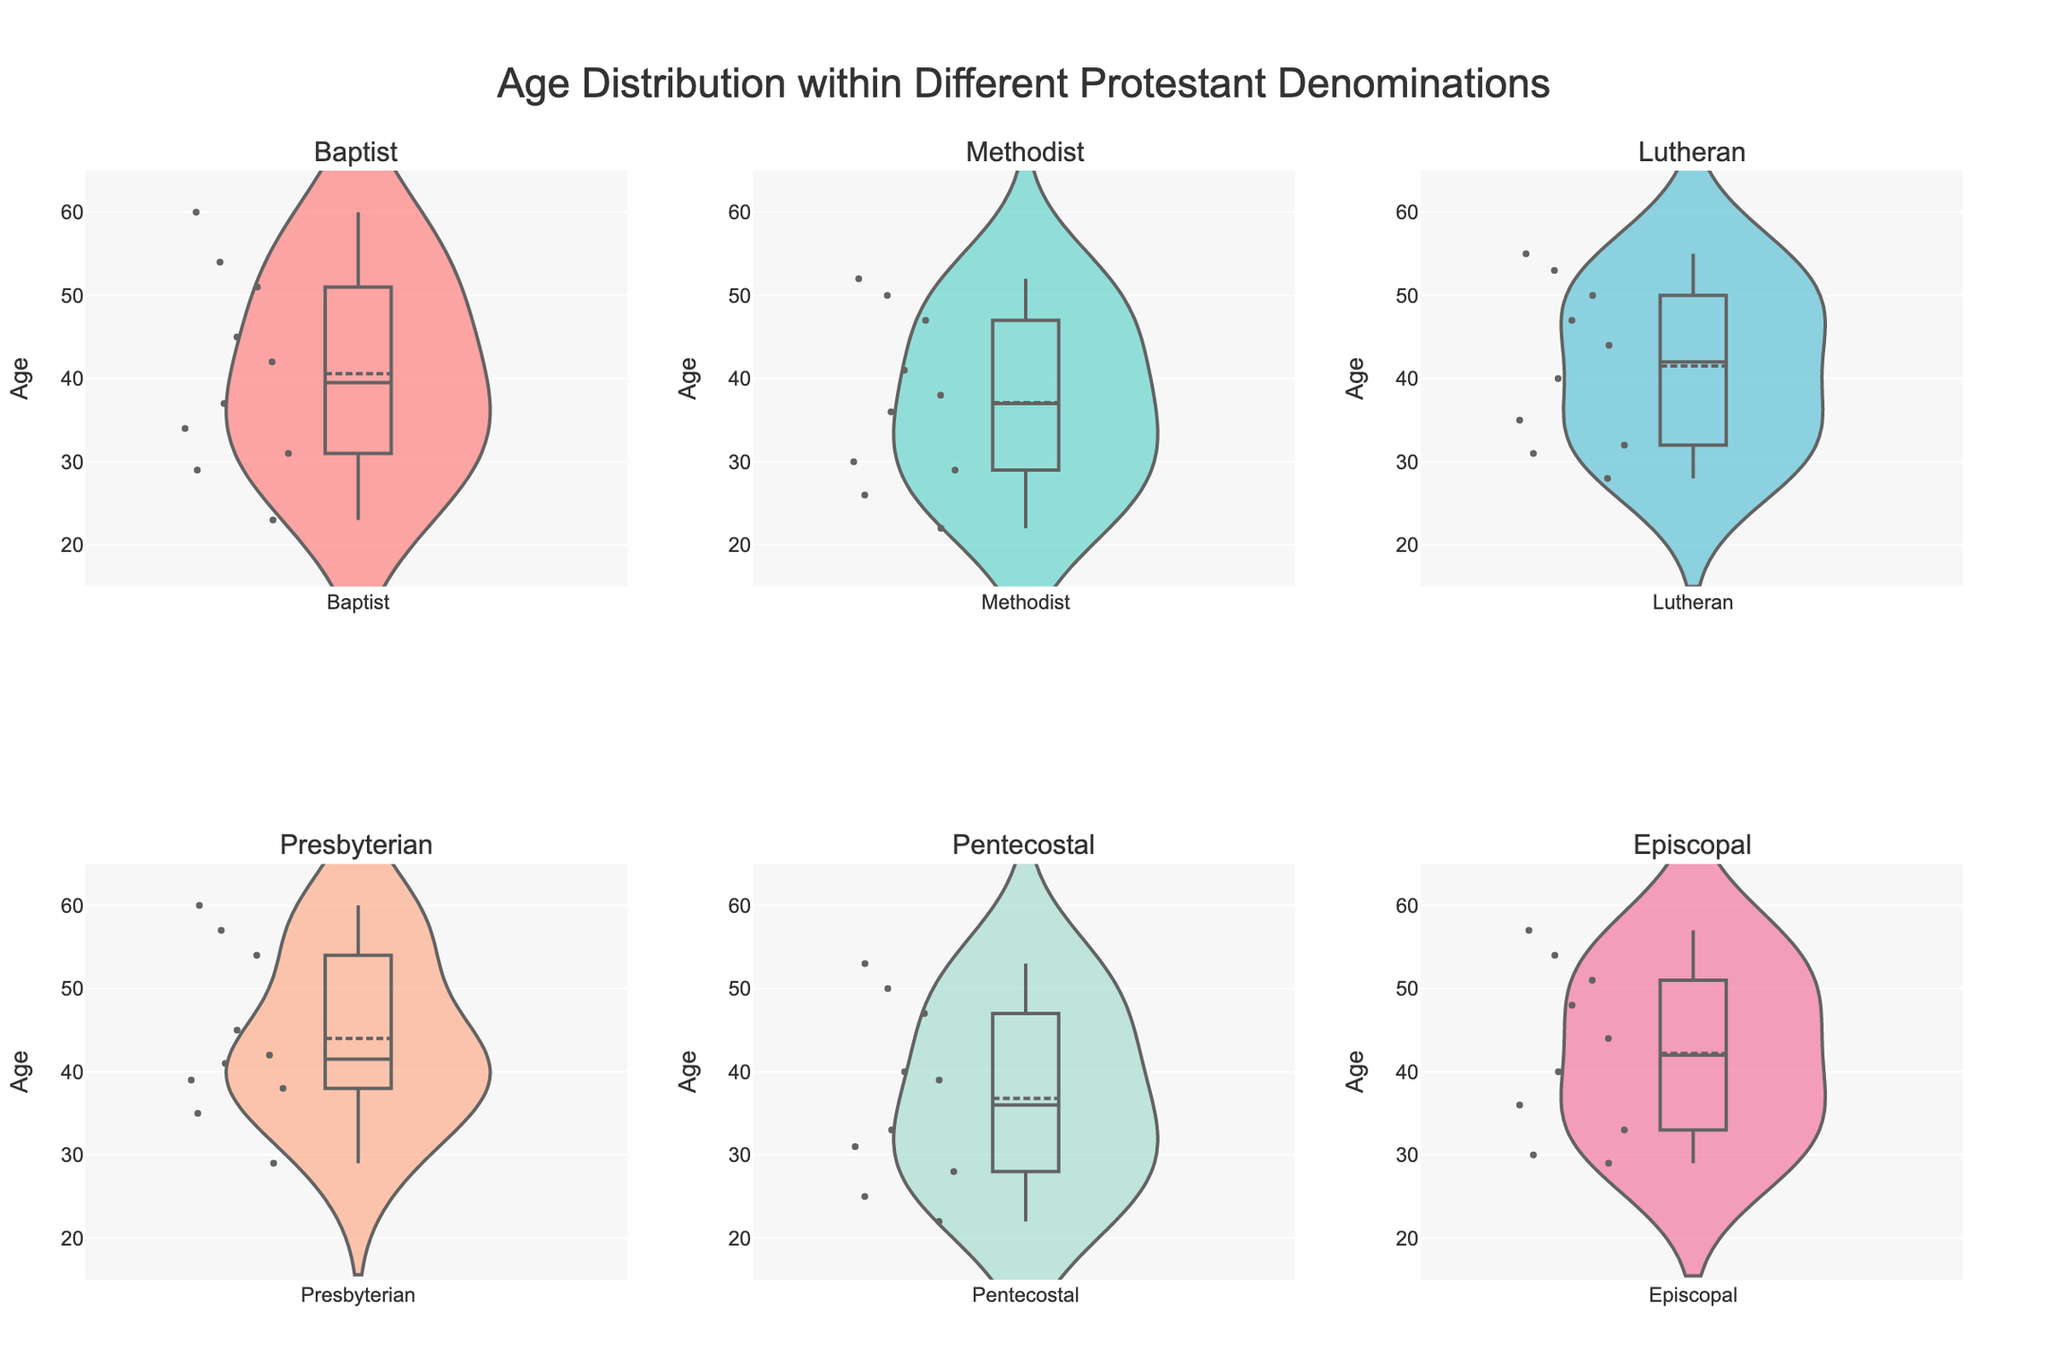What is the title of the figure? The title is usually displayed at the top of the figure and provides an overview of what the figure is about. The title of this figure is "Age Distribution within Different Protestant Denominations"
Answer: Age Distribution within Different Protestant Denominations What is the range of ages displayed on the y-axis? The range of ages displayed on the y-axis is determined by the axis labels and gridlines. According to the layout settings, the age range is from 15 to 65.
Answer: 15 to 65 Which denomination has the widest age spread? To find the denomination with the widest age spread, look at the length of the violin plots vertically. The denomination where the violin plot spans the most age range is the one with the widest spread.
Answer: Presbyterian Which denomination has the highest median age? The median age can be indicated by a line within the violin plot. Identify which plot has the highest positioned median line.
Answer: Presbyterian What is the mean age for the Baptist denomination? Mean age is indicated by the mean line within the violin plot. For the Baptist denomination, locate the plot and read the position of the mean line.
Answer: 40 Which denomination seems to have the most concentrated (least dispersed) age range? The concentration or dispersion within a violin plot is visualized by its width or density. A narrower plot indicates less dispersion in ages.
Answer: Methodist Approximately how many data points are shown in the Lutheran denomination plot? Each individual age is shown as a point on the violin plot. Count these points within the Lutheran plot to estimate their number.
Answer: 10 Compare the median ages of the Episcopal and Pentecostal denominations. Which is higher? Look at the median line within each denomination's violin plot (Episcopal and Pentecostal) and compare their vertical positions.
Answer: Episcopal Are the age distributions for Methodist and Baptist denominations roughly symmetrical or skewed? Examine the shapes of the violin plots for symmetry. A symmetrical shape indicates a symmetric distribution, while an asymmetrical shape indicates skewness.
Answer: Baptist: Symmetrical, Methodist: Skewed What is the age range that contains the densest concentration of ages for the Pentecostal denomination? The densest concentration within a violin plot is where the plot is widest. Observe the Pentecostal plot and identify the range where it is the most expanded horizontally.
Answer: 22 to 33 